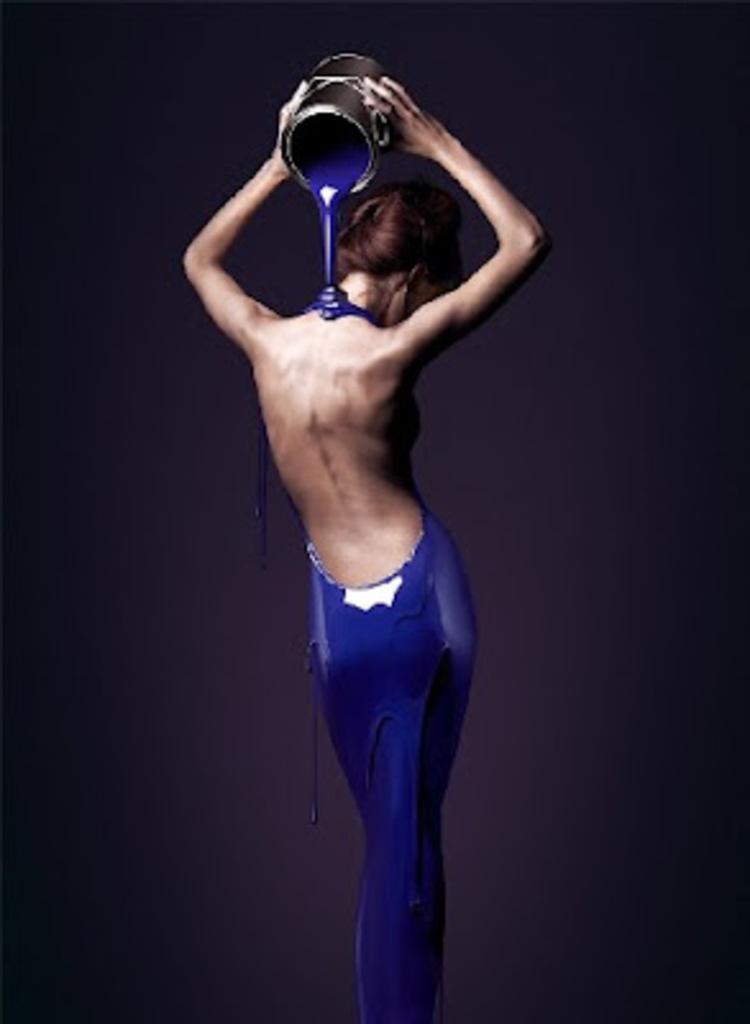Could you give a brief overview of what you see in this image? In the center of this image there is person standing, holding a pot and pouring a blue color paint on his body. The background of the image is dark. 